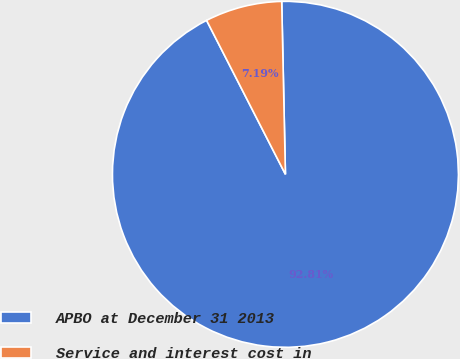Convert chart to OTSL. <chart><loc_0><loc_0><loc_500><loc_500><pie_chart><fcel>APBO at December 31 2013<fcel>Service and interest cost in<nl><fcel>92.81%<fcel>7.19%<nl></chart> 